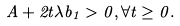<formula> <loc_0><loc_0><loc_500><loc_500>A + 2 t \lambda b _ { 1 } > 0 , \forall t \geq 0 .</formula> 